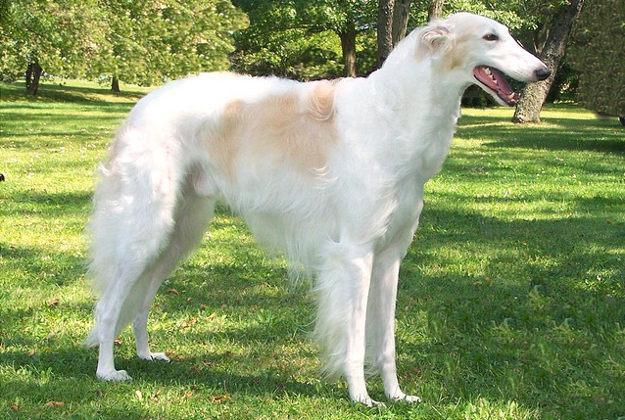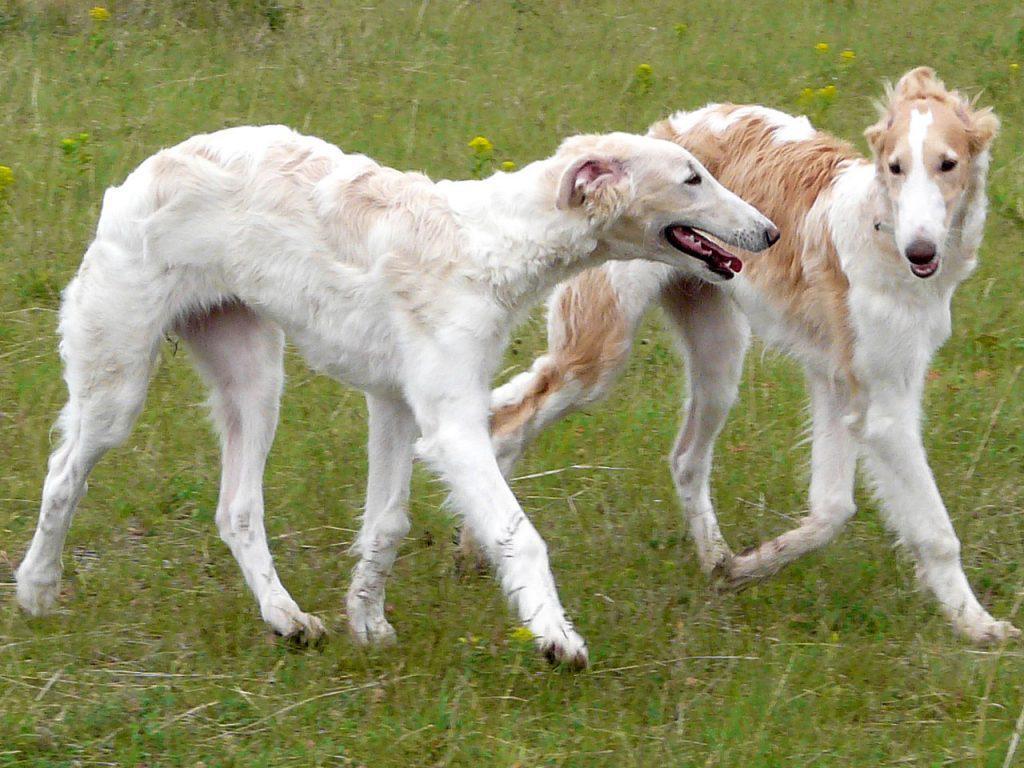The first image is the image on the left, the second image is the image on the right. Analyze the images presented: Is the assertion "All dogs pictured are standing on all fours on grass, and the right image contains more dogs than the left." valid? Answer yes or no. Yes. The first image is the image on the left, the second image is the image on the right. Examine the images to the left and right. Is the description "In one of the images there are two dogs standing in the grass in close proximity to each other." accurate? Answer yes or no. Yes. 